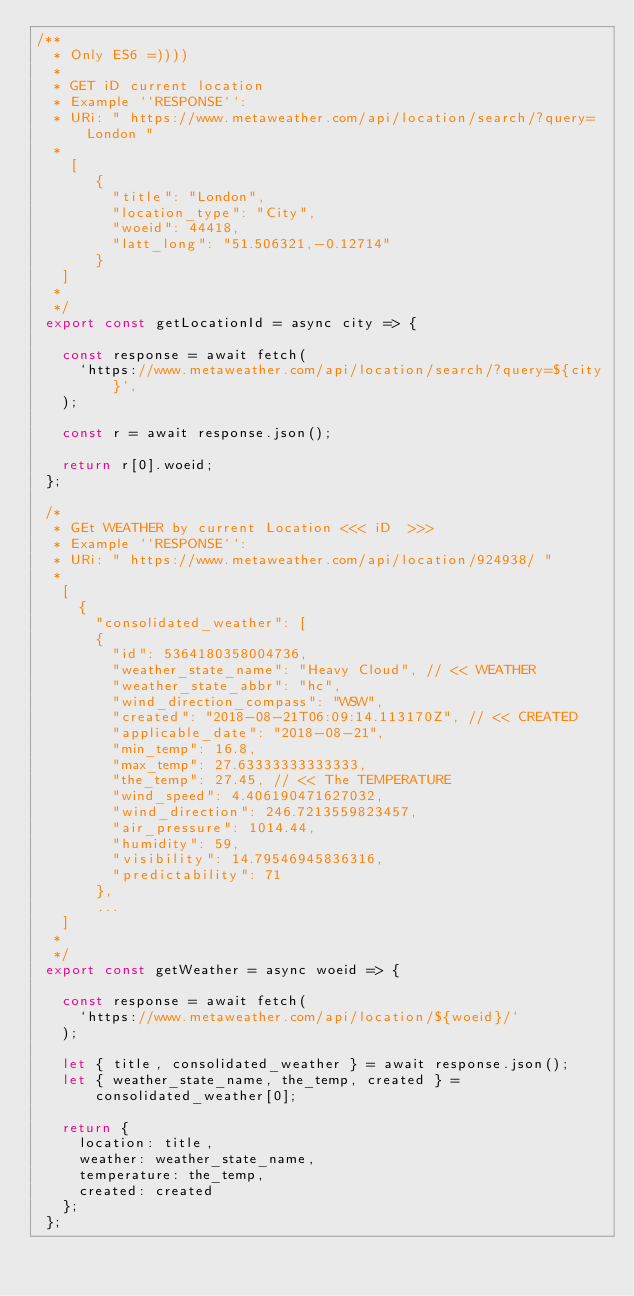<code> <loc_0><loc_0><loc_500><loc_500><_JavaScript_>/**
  * Only ES6 =))))
  *
  * GET iD current location
  * Example ``RESPONSE``:
  * URi: " https://www.metaweather.com/api/location/search/?query=London "
  *
    [
       {
         "title": "London",
         "location_type": "City",
         "woeid": 44418,
         "latt_long": "51.506321,-0.12714"
       }
   ]
  *
  */
 export const getLocationId = async city => {
 
   const response = await fetch(
     `https://www.metaweather.com/api/location/search/?query=${city}`,
   );
 
   const r = await response.json();
 
   return r[0].woeid;
 };
 
 /*
  * GEt WEATHER by current Location <<< iD  >>>
  * Example ``RESPONSE``:
  * URi: " https://www.metaweather.com/api/location/924938/ "
  *
   [
     {
       "consolidated_weather": [
       {
         "id": 5364180358004736,
         "weather_state_name": "Heavy Cloud", // << WEATHER
         "weather_state_abbr": "hc",
         "wind_direction_compass": "WSW",
         "created": "2018-08-21T06:09:14.113170Z", // << CREATED
         "applicable_date": "2018-08-21",
         "min_temp": 16.8,
         "max_temp": 27.63333333333333,
         "the_temp": 27.45, // << The TEMPERATURE
         "wind_speed": 4.406190471627032,
         "wind_direction": 246.7213559823457,
         "air_pressure": 1014.44,
         "humidity": 59,
         "visibility": 14.79546945836316,
         "predictability": 71
       },
       ...
   ]
  *
  */
 export const getWeather = async woeid => {
 
   const response = await fetch(
     `https://www.metaweather.com/api/location/${woeid}/`
   );
 
   let { title, consolidated_weather } = await response.json();
   let { weather_state_name, the_temp, created } = consolidated_weather[0];
 
   return {
     location: title,
     weather: weather_state_name,
     temperature: the_temp,
     created: created
   };
 };</code> 